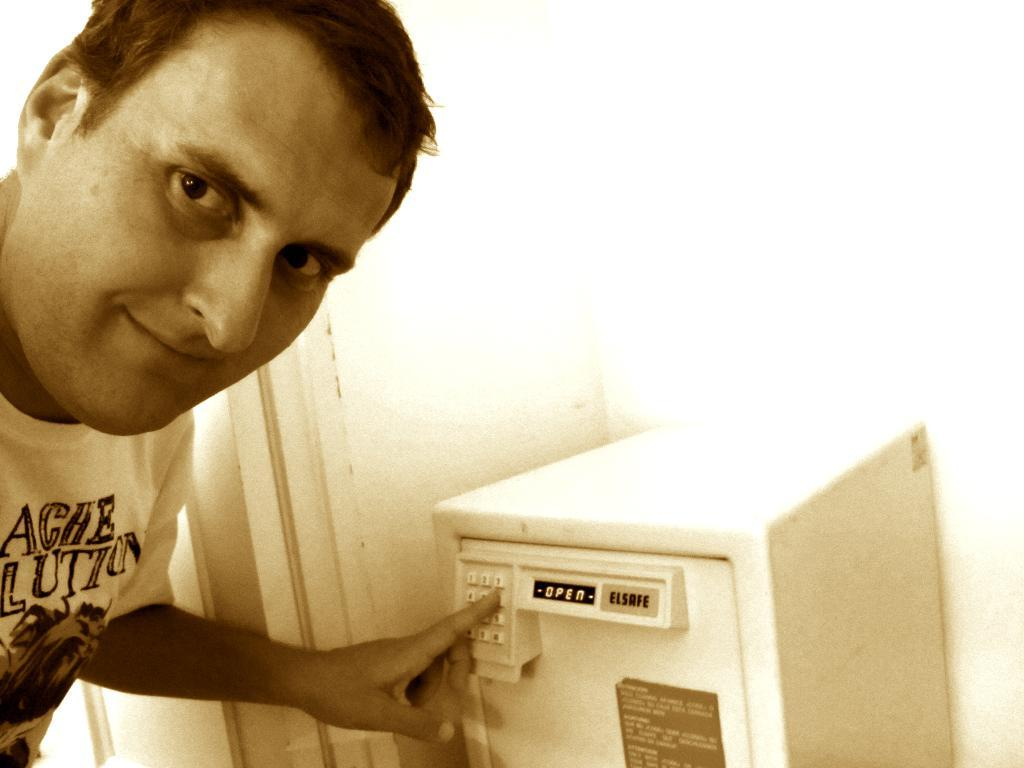What is located on the left side of the image? There is a man on the left side of the image. What is the man wearing? The man is wearing a t-shirt. What is the man doing in the image? The man is looking at a picture. What can be seen beside the man? There is a machine tool beside the man. What is visible in the background of the image? There is a wall in the background of the image. How many apples are on the rail in the image? There are no apples or rails present in the image. What is the man doing with his finger in the image? There is no mention of the man using his finger in the image; he is simply looking at a picture. 